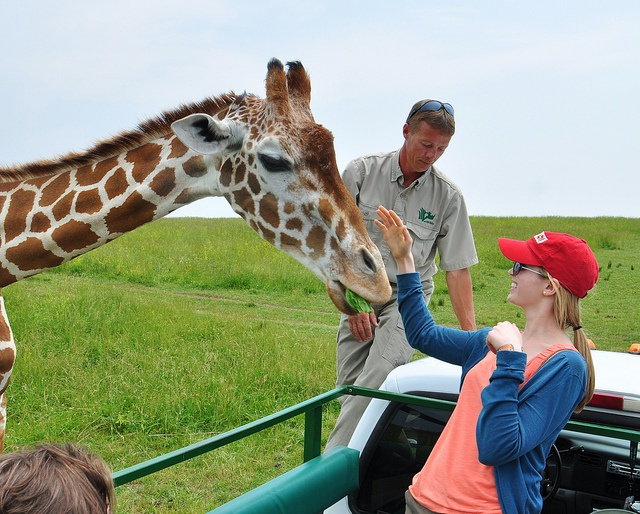Describe the objects in this image and their specific colors. I can see giraffe in lavender, darkgray, maroon, and black tones, people in lavender, navy, salmon, blue, and darkblue tones, truck in lavender, black, white, lightblue, and teal tones, people in lavender, darkgray, gray, and brown tones, and people in lavender, gray, and black tones in this image. 